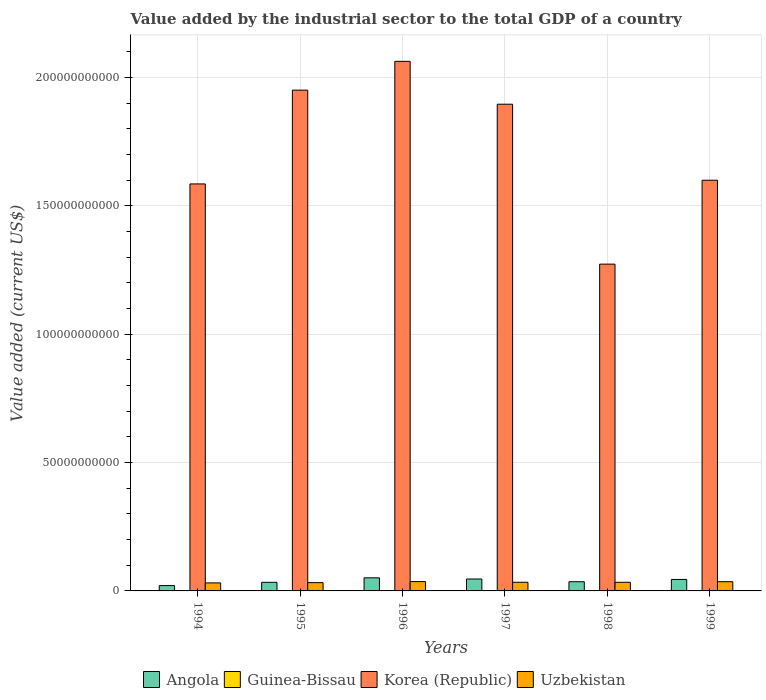How many different coloured bars are there?
Offer a very short reply. 4. How many groups of bars are there?
Provide a short and direct response. 6. Are the number of bars per tick equal to the number of legend labels?
Ensure brevity in your answer.  Yes. Are the number of bars on each tick of the X-axis equal?
Keep it short and to the point. Yes. How many bars are there on the 5th tick from the right?
Your answer should be very brief. 4. What is the value added by the industrial sector to the total GDP in Uzbekistan in 1995?
Give a very brief answer. 3.22e+09. Across all years, what is the maximum value added by the industrial sector to the total GDP in Uzbekistan?
Provide a succinct answer. 3.64e+09. Across all years, what is the minimum value added by the industrial sector to the total GDP in Guinea-Bissau?
Ensure brevity in your answer.  2.56e+07. In which year was the value added by the industrial sector to the total GDP in Angola maximum?
Provide a short and direct response. 1996. What is the total value added by the industrial sector to the total GDP in Guinea-Bissau in the graph?
Offer a very short reply. 1.77e+08. What is the difference between the value added by the industrial sector to the total GDP in Guinea-Bissau in 1996 and that in 1999?
Provide a succinct answer. 2.37e+06. What is the difference between the value added by the industrial sector to the total GDP in Korea (Republic) in 1998 and the value added by the industrial sector to the total GDP in Guinea-Bissau in 1995?
Keep it short and to the point. 1.27e+11. What is the average value added by the industrial sector to the total GDP in Korea (Republic) per year?
Provide a short and direct response. 1.73e+11. In the year 1995, what is the difference between the value added by the industrial sector to the total GDP in Guinea-Bissau and value added by the industrial sector to the total GDP in Angola?
Provide a succinct answer. -3.32e+09. In how many years, is the value added by the industrial sector to the total GDP in Uzbekistan greater than 110000000000 US$?
Offer a very short reply. 0. What is the ratio of the value added by the industrial sector to the total GDP in Angola in 1996 to that in 1997?
Offer a terse response. 1.1. Is the value added by the industrial sector to the total GDP in Uzbekistan in 1995 less than that in 1996?
Offer a very short reply. Yes. What is the difference between the highest and the second highest value added by the industrial sector to the total GDP in Uzbekistan?
Ensure brevity in your answer.  4.40e+07. What is the difference between the highest and the lowest value added by the industrial sector to the total GDP in Guinea-Bissau?
Provide a short and direct response. 1.48e+07. In how many years, is the value added by the industrial sector to the total GDP in Guinea-Bissau greater than the average value added by the industrial sector to the total GDP in Guinea-Bissau taken over all years?
Offer a very short reply. 1. Is the sum of the value added by the industrial sector to the total GDP in Guinea-Bissau in 1995 and 1997 greater than the maximum value added by the industrial sector to the total GDP in Angola across all years?
Provide a short and direct response. No. Is it the case that in every year, the sum of the value added by the industrial sector to the total GDP in Korea (Republic) and value added by the industrial sector to the total GDP in Uzbekistan is greater than the sum of value added by the industrial sector to the total GDP in Angola and value added by the industrial sector to the total GDP in Guinea-Bissau?
Keep it short and to the point. Yes. What does the 1st bar from the left in 1998 represents?
Your answer should be very brief. Angola. What does the 1st bar from the right in 1996 represents?
Provide a succinct answer. Uzbekistan. Is it the case that in every year, the sum of the value added by the industrial sector to the total GDP in Uzbekistan and value added by the industrial sector to the total GDP in Korea (Republic) is greater than the value added by the industrial sector to the total GDP in Guinea-Bissau?
Your answer should be very brief. Yes. How many years are there in the graph?
Your answer should be compact. 6. What is the difference between two consecutive major ticks on the Y-axis?
Your answer should be very brief. 5.00e+1. Are the values on the major ticks of Y-axis written in scientific E-notation?
Keep it short and to the point. No. Does the graph contain any zero values?
Make the answer very short. No. Where does the legend appear in the graph?
Provide a short and direct response. Bottom center. What is the title of the graph?
Offer a very short reply. Value added by the industrial sector to the total GDP of a country. Does "Indonesia" appear as one of the legend labels in the graph?
Offer a terse response. No. What is the label or title of the Y-axis?
Give a very brief answer. Value added (current US$). What is the Value added (current US$) of Angola in 1994?
Make the answer very short. 2.08e+09. What is the Value added (current US$) in Guinea-Bissau in 1994?
Your response must be concise. 2.56e+07. What is the Value added (current US$) in Korea (Republic) in 1994?
Give a very brief answer. 1.59e+11. What is the Value added (current US$) of Uzbekistan in 1994?
Your answer should be very brief. 3.13e+09. What is the Value added (current US$) of Angola in 1995?
Your answer should be very brief. 3.35e+09. What is the Value added (current US$) of Guinea-Bissau in 1995?
Your answer should be very brief. 2.91e+07. What is the Value added (current US$) of Korea (Republic) in 1995?
Offer a terse response. 1.95e+11. What is the Value added (current US$) of Uzbekistan in 1995?
Offer a very short reply. 3.22e+09. What is the Value added (current US$) of Angola in 1996?
Provide a succinct answer. 5.10e+09. What is the Value added (current US$) in Guinea-Bissau in 1996?
Offer a terse response. 2.95e+07. What is the Value added (current US$) in Korea (Republic) in 1996?
Provide a succinct answer. 2.06e+11. What is the Value added (current US$) of Uzbekistan in 1996?
Your answer should be very brief. 3.64e+09. What is the Value added (current US$) in Angola in 1997?
Your answer should be very brief. 4.65e+09. What is the Value added (current US$) in Guinea-Bissau in 1997?
Your response must be concise. 4.04e+07. What is the Value added (current US$) in Korea (Republic) in 1997?
Offer a terse response. 1.90e+11. What is the Value added (current US$) in Uzbekistan in 1997?
Make the answer very short. 3.37e+09. What is the Value added (current US$) of Angola in 1998?
Provide a short and direct response. 3.59e+09. What is the Value added (current US$) of Guinea-Bissau in 1998?
Provide a succinct answer. 2.58e+07. What is the Value added (current US$) of Korea (Republic) in 1998?
Make the answer very short. 1.27e+11. What is the Value added (current US$) in Uzbekistan in 1998?
Offer a terse response. 3.36e+09. What is the Value added (current US$) of Angola in 1999?
Provide a succinct answer. 4.47e+09. What is the Value added (current US$) of Guinea-Bissau in 1999?
Ensure brevity in your answer.  2.71e+07. What is the Value added (current US$) in Korea (Republic) in 1999?
Your answer should be very brief. 1.60e+11. What is the Value added (current US$) in Uzbekistan in 1999?
Provide a succinct answer. 3.59e+09. Across all years, what is the maximum Value added (current US$) in Angola?
Ensure brevity in your answer.  5.10e+09. Across all years, what is the maximum Value added (current US$) in Guinea-Bissau?
Make the answer very short. 4.04e+07. Across all years, what is the maximum Value added (current US$) of Korea (Republic)?
Keep it short and to the point. 2.06e+11. Across all years, what is the maximum Value added (current US$) in Uzbekistan?
Ensure brevity in your answer.  3.64e+09. Across all years, what is the minimum Value added (current US$) of Angola?
Provide a short and direct response. 2.08e+09. Across all years, what is the minimum Value added (current US$) of Guinea-Bissau?
Make the answer very short. 2.56e+07. Across all years, what is the minimum Value added (current US$) in Korea (Republic)?
Offer a very short reply. 1.27e+11. Across all years, what is the minimum Value added (current US$) of Uzbekistan?
Your response must be concise. 3.13e+09. What is the total Value added (current US$) in Angola in the graph?
Provide a succinct answer. 2.32e+1. What is the total Value added (current US$) in Guinea-Bissau in the graph?
Give a very brief answer. 1.77e+08. What is the total Value added (current US$) in Korea (Republic) in the graph?
Ensure brevity in your answer.  1.04e+12. What is the total Value added (current US$) in Uzbekistan in the graph?
Your answer should be compact. 2.03e+1. What is the difference between the Value added (current US$) of Angola in 1994 and that in 1995?
Offer a very short reply. -1.28e+09. What is the difference between the Value added (current US$) in Guinea-Bissau in 1994 and that in 1995?
Offer a very short reply. -3.55e+06. What is the difference between the Value added (current US$) in Korea (Republic) in 1994 and that in 1995?
Make the answer very short. -3.65e+1. What is the difference between the Value added (current US$) of Uzbekistan in 1994 and that in 1995?
Your answer should be very brief. -9.48e+07. What is the difference between the Value added (current US$) in Angola in 1994 and that in 1996?
Ensure brevity in your answer.  -3.03e+09. What is the difference between the Value added (current US$) in Guinea-Bissau in 1994 and that in 1996?
Give a very brief answer. -3.89e+06. What is the difference between the Value added (current US$) of Korea (Republic) in 1994 and that in 1996?
Keep it short and to the point. -4.78e+1. What is the difference between the Value added (current US$) of Uzbekistan in 1994 and that in 1996?
Your answer should be very brief. -5.10e+08. What is the difference between the Value added (current US$) of Angola in 1994 and that in 1997?
Ensure brevity in your answer.  -2.57e+09. What is the difference between the Value added (current US$) of Guinea-Bissau in 1994 and that in 1997?
Provide a short and direct response. -1.48e+07. What is the difference between the Value added (current US$) in Korea (Republic) in 1994 and that in 1997?
Your answer should be very brief. -3.11e+1. What is the difference between the Value added (current US$) of Uzbekistan in 1994 and that in 1997?
Provide a short and direct response. -2.44e+08. What is the difference between the Value added (current US$) in Angola in 1994 and that in 1998?
Keep it short and to the point. -1.51e+09. What is the difference between the Value added (current US$) of Guinea-Bissau in 1994 and that in 1998?
Offer a terse response. -1.60e+05. What is the difference between the Value added (current US$) of Korea (Republic) in 1994 and that in 1998?
Give a very brief answer. 3.13e+1. What is the difference between the Value added (current US$) of Uzbekistan in 1994 and that in 1998?
Provide a short and direct response. -2.29e+08. What is the difference between the Value added (current US$) in Angola in 1994 and that in 1999?
Your answer should be very brief. -2.40e+09. What is the difference between the Value added (current US$) in Guinea-Bissau in 1994 and that in 1999?
Ensure brevity in your answer.  -1.52e+06. What is the difference between the Value added (current US$) of Korea (Republic) in 1994 and that in 1999?
Make the answer very short. -1.44e+09. What is the difference between the Value added (current US$) of Uzbekistan in 1994 and that in 1999?
Offer a very short reply. -4.66e+08. What is the difference between the Value added (current US$) in Angola in 1995 and that in 1996?
Your answer should be very brief. -1.75e+09. What is the difference between the Value added (current US$) of Guinea-Bissau in 1995 and that in 1996?
Give a very brief answer. -3.42e+05. What is the difference between the Value added (current US$) in Korea (Republic) in 1995 and that in 1996?
Keep it short and to the point. -1.12e+1. What is the difference between the Value added (current US$) in Uzbekistan in 1995 and that in 1996?
Offer a terse response. -4.15e+08. What is the difference between the Value added (current US$) of Angola in 1995 and that in 1997?
Your response must be concise. -1.30e+09. What is the difference between the Value added (current US$) in Guinea-Bissau in 1995 and that in 1997?
Ensure brevity in your answer.  -1.12e+07. What is the difference between the Value added (current US$) in Korea (Republic) in 1995 and that in 1997?
Your response must be concise. 5.48e+09. What is the difference between the Value added (current US$) in Uzbekistan in 1995 and that in 1997?
Offer a terse response. -1.49e+08. What is the difference between the Value added (current US$) in Angola in 1995 and that in 1998?
Offer a terse response. -2.36e+08. What is the difference between the Value added (current US$) of Guinea-Bissau in 1995 and that in 1998?
Make the answer very short. 3.38e+06. What is the difference between the Value added (current US$) in Korea (Republic) in 1995 and that in 1998?
Your answer should be very brief. 6.78e+1. What is the difference between the Value added (current US$) in Uzbekistan in 1995 and that in 1998?
Keep it short and to the point. -1.34e+08. What is the difference between the Value added (current US$) in Angola in 1995 and that in 1999?
Give a very brief answer. -1.12e+09. What is the difference between the Value added (current US$) in Guinea-Bissau in 1995 and that in 1999?
Keep it short and to the point. 2.02e+06. What is the difference between the Value added (current US$) in Korea (Republic) in 1995 and that in 1999?
Your answer should be compact. 3.51e+1. What is the difference between the Value added (current US$) of Uzbekistan in 1995 and that in 1999?
Your answer should be very brief. -3.71e+08. What is the difference between the Value added (current US$) in Angola in 1996 and that in 1997?
Keep it short and to the point. 4.57e+08. What is the difference between the Value added (current US$) of Guinea-Bissau in 1996 and that in 1997?
Your answer should be very brief. -1.09e+07. What is the difference between the Value added (current US$) of Korea (Republic) in 1996 and that in 1997?
Give a very brief answer. 1.67e+1. What is the difference between the Value added (current US$) in Uzbekistan in 1996 and that in 1997?
Offer a terse response. 2.66e+08. What is the difference between the Value added (current US$) of Angola in 1996 and that in 1998?
Ensure brevity in your answer.  1.52e+09. What is the difference between the Value added (current US$) in Guinea-Bissau in 1996 and that in 1998?
Your response must be concise. 3.73e+06. What is the difference between the Value added (current US$) in Korea (Republic) in 1996 and that in 1998?
Your answer should be compact. 7.90e+1. What is the difference between the Value added (current US$) in Uzbekistan in 1996 and that in 1998?
Ensure brevity in your answer.  2.81e+08. What is the difference between the Value added (current US$) of Angola in 1996 and that in 1999?
Your answer should be very brief. 6.31e+08. What is the difference between the Value added (current US$) of Guinea-Bissau in 1996 and that in 1999?
Your answer should be very brief. 2.37e+06. What is the difference between the Value added (current US$) in Korea (Republic) in 1996 and that in 1999?
Offer a terse response. 4.63e+1. What is the difference between the Value added (current US$) in Uzbekistan in 1996 and that in 1999?
Provide a succinct answer. 4.40e+07. What is the difference between the Value added (current US$) of Angola in 1997 and that in 1998?
Keep it short and to the point. 1.06e+09. What is the difference between the Value added (current US$) of Guinea-Bissau in 1997 and that in 1998?
Offer a terse response. 1.46e+07. What is the difference between the Value added (current US$) of Korea (Republic) in 1997 and that in 1998?
Give a very brief answer. 6.23e+1. What is the difference between the Value added (current US$) in Uzbekistan in 1997 and that in 1998?
Offer a very short reply. 1.51e+07. What is the difference between the Value added (current US$) in Angola in 1997 and that in 1999?
Ensure brevity in your answer.  1.74e+08. What is the difference between the Value added (current US$) of Guinea-Bissau in 1997 and that in 1999?
Offer a terse response. 1.32e+07. What is the difference between the Value added (current US$) in Korea (Republic) in 1997 and that in 1999?
Offer a terse response. 2.96e+1. What is the difference between the Value added (current US$) in Uzbekistan in 1997 and that in 1999?
Your response must be concise. -2.22e+08. What is the difference between the Value added (current US$) in Angola in 1998 and that in 1999?
Provide a short and direct response. -8.85e+08. What is the difference between the Value added (current US$) of Guinea-Bissau in 1998 and that in 1999?
Offer a terse response. -1.36e+06. What is the difference between the Value added (current US$) in Korea (Republic) in 1998 and that in 1999?
Offer a very short reply. -3.27e+1. What is the difference between the Value added (current US$) in Uzbekistan in 1998 and that in 1999?
Ensure brevity in your answer.  -2.37e+08. What is the difference between the Value added (current US$) in Angola in 1994 and the Value added (current US$) in Guinea-Bissau in 1995?
Make the answer very short. 2.05e+09. What is the difference between the Value added (current US$) in Angola in 1994 and the Value added (current US$) in Korea (Republic) in 1995?
Keep it short and to the point. -1.93e+11. What is the difference between the Value added (current US$) of Angola in 1994 and the Value added (current US$) of Uzbekistan in 1995?
Keep it short and to the point. -1.15e+09. What is the difference between the Value added (current US$) of Guinea-Bissau in 1994 and the Value added (current US$) of Korea (Republic) in 1995?
Give a very brief answer. -1.95e+11. What is the difference between the Value added (current US$) of Guinea-Bissau in 1994 and the Value added (current US$) of Uzbekistan in 1995?
Keep it short and to the point. -3.20e+09. What is the difference between the Value added (current US$) of Korea (Republic) in 1994 and the Value added (current US$) of Uzbekistan in 1995?
Your answer should be compact. 1.55e+11. What is the difference between the Value added (current US$) in Angola in 1994 and the Value added (current US$) in Guinea-Bissau in 1996?
Provide a short and direct response. 2.05e+09. What is the difference between the Value added (current US$) of Angola in 1994 and the Value added (current US$) of Korea (Republic) in 1996?
Keep it short and to the point. -2.04e+11. What is the difference between the Value added (current US$) of Angola in 1994 and the Value added (current US$) of Uzbekistan in 1996?
Offer a very short reply. -1.56e+09. What is the difference between the Value added (current US$) of Guinea-Bissau in 1994 and the Value added (current US$) of Korea (Republic) in 1996?
Ensure brevity in your answer.  -2.06e+11. What is the difference between the Value added (current US$) in Guinea-Bissau in 1994 and the Value added (current US$) in Uzbekistan in 1996?
Ensure brevity in your answer.  -3.61e+09. What is the difference between the Value added (current US$) of Korea (Republic) in 1994 and the Value added (current US$) of Uzbekistan in 1996?
Your answer should be compact. 1.55e+11. What is the difference between the Value added (current US$) of Angola in 1994 and the Value added (current US$) of Guinea-Bissau in 1997?
Your answer should be compact. 2.04e+09. What is the difference between the Value added (current US$) of Angola in 1994 and the Value added (current US$) of Korea (Republic) in 1997?
Your answer should be compact. -1.88e+11. What is the difference between the Value added (current US$) of Angola in 1994 and the Value added (current US$) of Uzbekistan in 1997?
Make the answer very short. -1.30e+09. What is the difference between the Value added (current US$) of Guinea-Bissau in 1994 and the Value added (current US$) of Korea (Republic) in 1997?
Your answer should be compact. -1.90e+11. What is the difference between the Value added (current US$) of Guinea-Bissau in 1994 and the Value added (current US$) of Uzbekistan in 1997?
Provide a succinct answer. -3.35e+09. What is the difference between the Value added (current US$) of Korea (Republic) in 1994 and the Value added (current US$) of Uzbekistan in 1997?
Offer a very short reply. 1.55e+11. What is the difference between the Value added (current US$) of Angola in 1994 and the Value added (current US$) of Guinea-Bissau in 1998?
Provide a short and direct response. 2.05e+09. What is the difference between the Value added (current US$) of Angola in 1994 and the Value added (current US$) of Korea (Republic) in 1998?
Provide a succinct answer. -1.25e+11. What is the difference between the Value added (current US$) in Angola in 1994 and the Value added (current US$) in Uzbekistan in 1998?
Give a very brief answer. -1.28e+09. What is the difference between the Value added (current US$) of Guinea-Bissau in 1994 and the Value added (current US$) of Korea (Republic) in 1998?
Provide a succinct answer. -1.27e+11. What is the difference between the Value added (current US$) of Guinea-Bissau in 1994 and the Value added (current US$) of Uzbekistan in 1998?
Ensure brevity in your answer.  -3.33e+09. What is the difference between the Value added (current US$) in Korea (Republic) in 1994 and the Value added (current US$) in Uzbekistan in 1998?
Give a very brief answer. 1.55e+11. What is the difference between the Value added (current US$) of Angola in 1994 and the Value added (current US$) of Guinea-Bissau in 1999?
Your answer should be very brief. 2.05e+09. What is the difference between the Value added (current US$) in Angola in 1994 and the Value added (current US$) in Korea (Republic) in 1999?
Give a very brief answer. -1.58e+11. What is the difference between the Value added (current US$) in Angola in 1994 and the Value added (current US$) in Uzbekistan in 1999?
Your answer should be very brief. -1.52e+09. What is the difference between the Value added (current US$) in Guinea-Bissau in 1994 and the Value added (current US$) in Korea (Republic) in 1999?
Offer a terse response. -1.60e+11. What is the difference between the Value added (current US$) in Guinea-Bissau in 1994 and the Value added (current US$) in Uzbekistan in 1999?
Offer a terse response. -3.57e+09. What is the difference between the Value added (current US$) of Korea (Republic) in 1994 and the Value added (current US$) of Uzbekistan in 1999?
Provide a short and direct response. 1.55e+11. What is the difference between the Value added (current US$) of Angola in 1995 and the Value added (current US$) of Guinea-Bissau in 1996?
Provide a short and direct response. 3.32e+09. What is the difference between the Value added (current US$) of Angola in 1995 and the Value added (current US$) of Korea (Republic) in 1996?
Offer a very short reply. -2.03e+11. What is the difference between the Value added (current US$) in Angola in 1995 and the Value added (current US$) in Uzbekistan in 1996?
Give a very brief answer. -2.86e+08. What is the difference between the Value added (current US$) in Guinea-Bissau in 1995 and the Value added (current US$) in Korea (Republic) in 1996?
Offer a very short reply. -2.06e+11. What is the difference between the Value added (current US$) in Guinea-Bissau in 1995 and the Value added (current US$) in Uzbekistan in 1996?
Offer a very short reply. -3.61e+09. What is the difference between the Value added (current US$) of Korea (Republic) in 1995 and the Value added (current US$) of Uzbekistan in 1996?
Ensure brevity in your answer.  1.91e+11. What is the difference between the Value added (current US$) of Angola in 1995 and the Value added (current US$) of Guinea-Bissau in 1997?
Give a very brief answer. 3.31e+09. What is the difference between the Value added (current US$) of Angola in 1995 and the Value added (current US$) of Korea (Republic) in 1997?
Your answer should be compact. -1.86e+11. What is the difference between the Value added (current US$) of Angola in 1995 and the Value added (current US$) of Uzbekistan in 1997?
Make the answer very short. -2.00e+07. What is the difference between the Value added (current US$) of Guinea-Bissau in 1995 and the Value added (current US$) of Korea (Republic) in 1997?
Keep it short and to the point. -1.90e+11. What is the difference between the Value added (current US$) in Guinea-Bissau in 1995 and the Value added (current US$) in Uzbekistan in 1997?
Provide a succinct answer. -3.34e+09. What is the difference between the Value added (current US$) of Korea (Republic) in 1995 and the Value added (current US$) of Uzbekistan in 1997?
Your response must be concise. 1.92e+11. What is the difference between the Value added (current US$) of Angola in 1995 and the Value added (current US$) of Guinea-Bissau in 1998?
Provide a short and direct response. 3.33e+09. What is the difference between the Value added (current US$) of Angola in 1995 and the Value added (current US$) of Korea (Republic) in 1998?
Your answer should be very brief. -1.24e+11. What is the difference between the Value added (current US$) of Angola in 1995 and the Value added (current US$) of Uzbekistan in 1998?
Ensure brevity in your answer.  -4.94e+06. What is the difference between the Value added (current US$) in Guinea-Bissau in 1995 and the Value added (current US$) in Korea (Republic) in 1998?
Your answer should be very brief. -1.27e+11. What is the difference between the Value added (current US$) in Guinea-Bissau in 1995 and the Value added (current US$) in Uzbekistan in 1998?
Your response must be concise. -3.33e+09. What is the difference between the Value added (current US$) of Korea (Republic) in 1995 and the Value added (current US$) of Uzbekistan in 1998?
Offer a terse response. 1.92e+11. What is the difference between the Value added (current US$) of Angola in 1995 and the Value added (current US$) of Guinea-Bissau in 1999?
Keep it short and to the point. 3.33e+09. What is the difference between the Value added (current US$) in Angola in 1995 and the Value added (current US$) in Korea (Republic) in 1999?
Provide a succinct answer. -1.57e+11. What is the difference between the Value added (current US$) in Angola in 1995 and the Value added (current US$) in Uzbekistan in 1999?
Your answer should be compact. -2.42e+08. What is the difference between the Value added (current US$) in Guinea-Bissau in 1995 and the Value added (current US$) in Korea (Republic) in 1999?
Offer a terse response. -1.60e+11. What is the difference between the Value added (current US$) in Guinea-Bissau in 1995 and the Value added (current US$) in Uzbekistan in 1999?
Your answer should be very brief. -3.57e+09. What is the difference between the Value added (current US$) in Korea (Republic) in 1995 and the Value added (current US$) in Uzbekistan in 1999?
Your response must be concise. 1.92e+11. What is the difference between the Value added (current US$) in Angola in 1996 and the Value added (current US$) in Guinea-Bissau in 1997?
Your response must be concise. 5.06e+09. What is the difference between the Value added (current US$) in Angola in 1996 and the Value added (current US$) in Korea (Republic) in 1997?
Give a very brief answer. -1.85e+11. What is the difference between the Value added (current US$) in Angola in 1996 and the Value added (current US$) in Uzbekistan in 1997?
Ensure brevity in your answer.  1.73e+09. What is the difference between the Value added (current US$) in Guinea-Bissau in 1996 and the Value added (current US$) in Korea (Republic) in 1997?
Your answer should be very brief. -1.90e+11. What is the difference between the Value added (current US$) in Guinea-Bissau in 1996 and the Value added (current US$) in Uzbekistan in 1997?
Offer a terse response. -3.34e+09. What is the difference between the Value added (current US$) of Korea (Republic) in 1996 and the Value added (current US$) of Uzbekistan in 1997?
Provide a short and direct response. 2.03e+11. What is the difference between the Value added (current US$) in Angola in 1996 and the Value added (current US$) in Guinea-Bissau in 1998?
Your answer should be compact. 5.08e+09. What is the difference between the Value added (current US$) of Angola in 1996 and the Value added (current US$) of Korea (Republic) in 1998?
Your answer should be compact. -1.22e+11. What is the difference between the Value added (current US$) in Angola in 1996 and the Value added (current US$) in Uzbekistan in 1998?
Your answer should be very brief. 1.75e+09. What is the difference between the Value added (current US$) in Guinea-Bissau in 1996 and the Value added (current US$) in Korea (Republic) in 1998?
Your answer should be compact. -1.27e+11. What is the difference between the Value added (current US$) of Guinea-Bissau in 1996 and the Value added (current US$) of Uzbekistan in 1998?
Provide a short and direct response. -3.33e+09. What is the difference between the Value added (current US$) in Korea (Republic) in 1996 and the Value added (current US$) in Uzbekistan in 1998?
Offer a terse response. 2.03e+11. What is the difference between the Value added (current US$) in Angola in 1996 and the Value added (current US$) in Guinea-Bissau in 1999?
Give a very brief answer. 5.08e+09. What is the difference between the Value added (current US$) in Angola in 1996 and the Value added (current US$) in Korea (Republic) in 1999?
Offer a terse response. -1.55e+11. What is the difference between the Value added (current US$) in Angola in 1996 and the Value added (current US$) in Uzbekistan in 1999?
Your answer should be very brief. 1.51e+09. What is the difference between the Value added (current US$) in Guinea-Bissau in 1996 and the Value added (current US$) in Korea (Republic) in 1999?
Provide a short and direct response. -1.60e+11. What is the difference between the Value added (current US$) in Guinea-Bissau in 1996 and the Value added (current US$) in Uzbekistan in 1999?
Ensure brevity in your answer.  -3.56e+09. What is the difference between the Value added (current US$) of Korea (Republic) in 1996 and the Value added (current US$) of Uzbekistan in 1999?
Offer a very short reply. 2.03e+11. What is the difference between the Value added (current US$) of Angola in 1997 and the Value added (current US$) of Guinea-Bissau in 1998?
Ensure brevity in your answer.  4.62e+09. What is the difference between the Value added (current US$) of Angola in 1997 and the Value added (current US$) of Korea (Republic) in 1998?
Give a very brief answer. -1.23e+11. What is the difference between the Value added (current US$) in Angola in 1997 and the Value added (current US$) in Uzbekistan in 1998?
Make the answer very short. 1.29e+09. What is the difference between the Value added (current US$) of Guinea-Bissau in 1997 and the Value added (current US$) of Korea (Republic) in 1998?
Your answer should be very brief. -1.27e+11. What is the difference between the Value added (current US$) in Guinea-Bissau in 1997 and the Value added (current US$) in Uzbekistan in 1998?
Offer a very short reply. -3.32e+09. What is the difference between the Value added (current US$) in Korea (Republic) in 1997 and the Value added (current US$) in Uzbekistan in 1998?
Provide a short and direct response. 1.86e+11. What is the difference between the Value added (current US$) of Angola in 1997 and the Value added (current US$) of Guinea-Bissau in 1999?
Make the answer very short. 4.62e+09. What is the difference between the Value added (current US$) in Angola in 1997 and the Value added (current US$) in Korea (Republic) in 1999?
Offer a terse response. -1.55e+11. What is the difference between the Value added (current US$) in Angola in 1997 and the Value added (current US$) in Uzbekistan in 1999?
Your response must be concise. 1.05e+09. What is the difference between the Value added (current US$) of Guinea-Bissau in 1997 and the Value added (current US$) of Korea (Republic) in 1999?
Your answer should be very brief. -1.60e+11. What is the difference between the Value added (current US$) in Guinea-Bissau in 1997 and the Value added (current US$) in Uzbekistan in 1999?
Provide a succinct answer. -3.55e+09. What is the difference between the Value added (current US$) in Korea (Republic) in 1997 and the Value added (current US$) in Uzbekistan in 1999?
Your response must be concise. 1.86e+11. What is the difference between the Value added (current US$) of Angola in 1998 and the Value added (current US$) of Guinea-Bissau in 1999?
Provide a succinct answer. 3.56e+09. What is the difference between the Value added (current US$) of Angola in 1998 and the Value added (current US$) of Korea (Republic) in 1999?
Your response must be concise. -1.56e+11. What is the difference between the Value added (current US$) of Angola in 1998 and the Value added (current US$) of Uzbekistan in 1999?
Keep it short and to the point. -5.48e+06. What is the difference between the Value added (current US$) in Guinea-Bissau in 1998 and the Value added (current US$) in Korea (Republic) in 1999?
Give a very brief answer. -1.60e+11. What is the difference between the Value added (current US$) of Guinea-Bissau in 1998 and the Value added (current US$) of Uzbekistan in 1999?
Ensure brevity in your answer.  -3.57e+09. What is the difference between the Value added (current US$) in Korea (Republic) in 1998 and the Value added (current US$) in Uzbekistan in 1999?
Provide a short and direct response. 1.24e+11. What is the average Value added (current US$) in Angola per year?
Your answer should be very brief. 3.87e+09. What is the average Value added (current US$) of Guinea-Bissau per year?
Keep it short and to the point. 2.96e+07. What is the average Value added (current US$) of Korea (Republic) per year?
Your answer should be very brief. 1.73e+11. What is the average Value added (current US$) of Uzbekistan per year?
Keep it short and to the point. 3.39e+09. In the year 1994, what is the difference between the Value added (current US$) of Angola and Value added (current US$) of Guinea-Bissau?
Keep it short and to the point. 2.05e+09. In the year 1994, what is the difference between the Value added (current US$) of Angola and Value added (current US$) of Korea (Republic)?
Keep it short and to the point. -1.57e+11. In the year 1994, what is the difference between the Value added (current US$) of Angola and Value added (current US$) of Uzbekistan?
Your answer should be very brief. -1.05e+09. In the year 1994, what is the difference between the Value added (current US$) of Guinea-Bissau and Value added (current US$) of Korea (Republic)?
Provide a succinct answer. -1.59e+11. In the year 1994, what is the difference between the Value added (current US$) in Guinea-Bissau and Value added (current US$) in Uzbekistan?
Your answer should be compact. -3.10e+09. In the year 1994, what is the difference between the Value added (current US$) in Korea (Republic) and Value added (current US$) in Uzbekistan?
Your response must be concise. 1.55e+11. In the year 1995, what is the difference between the Value added (current US$) in Angola and Value added (current US$) in Guinea-Bissau?
Make the answer very short. 3.32e+09. In the year 1995, what is the difference between the Value added (current US$) of Angola and Value added (current US$) of Korea (Republic)?
Your response must be concise. -1.92e+11. In the year 1995, what is the difference between the Value added (current US$) in Angola and Value added (current US$) in Uzbekistan?
Your response must be concise. 1.29e+08. In the year 1995, what is the difference between the Value added (current US$) in Guinea-Bissau and Value added (current US$) in Korea (Republic)?
Provide a short and direct response. -1.95e+11. In the year 1995, what is the difference between the Value added (current US$) of Guinea-Bissau and Value added (current US$) of Uzbekistan?
Provide a succinct answer. -3.19e+09. In the year 1995, what is the difference between the Value added (current US$) of Korea (Republic) and Value added (current US$) of Uzbekistan?
Give a very brief answer. 1.92e+11. In the year 1996, what is the difference between the Value added (current US$) in Angola and Value added (current US$) in Guinea-Bissau?
Your answer should be very brief. 5.08e+09. In the year 1996, what is the difference between the Value added (current US$) in Angola and Value added (current US$) in Korea (Republic)?
Ensure brevity in your answer.  -2.01e+11. In the year 1996, what is the difference between the Value added (current US$) in Angola and Value added (current US$) in Uzbekistan?
Provide a short and direct response. 1.47e+09. In the year 1996, what is the difference between the Value added (current US$) of Guinea-Bissau and Value added (current US$) of Korea (Republic)?
Your response must be concise. -2.06e+11. In the year 1996, what is the difference between the Value added (current US$) of Guinea-Bissau and Value added (current US$) of Uzbekistan?
Your answer should be compact. -3.61e+09. In the year 1996, what is the difference between the Value added (current US$) in Korea (Republic) and Value added (current US$) in Uzbekistan?
Ensure brevity in your answer.  2.03e+11. In the year 1997, what is the difference between the Value added (current US$) of Angola and Value added (current US$) of Guinea-Bissau?
Make the answer very short. 4.61e+09. In the year 1997, what is the difference between the Value added (current US$) of Angola and Value added (current US$) of Korea (Republic)?
Provide a succinct answer. -1.85e+11. In the year 1997, what is the difference between the Value added (current US$) of Angola and Value added (current US$) of Uzbekistan?
Your answer should be compact. 1.28e+09. In the year 1997, what is the difference between the Value added (current US$) of Guinea-Bissau and Value added (current US$) of Korea (Republic)?
Offer a very short reply. -1.90e+11. In the year 1997, what is the difference between the Value added (current US$) of Guinea-Bissau and Value added (current US$) of Uzbekistan?
Your answer should be very brief. -3.33e+09. In the year 1997, what is the difference between the Value added (current US$) of Korea (Republic) and Value added (current US$) of Uzbekistan?
Ensure brevity in your answer.  1.86e+11. In the year 1998, what is the difference between the Value added (current US$) of Angola and Value added (current US$) of Guinea-Bissau?
Provide a succinct answer. 3.56e+09. In the year 1998, what is the difference between the Value added (current US$) of Angola and Value added (current US$) of Korea (Republic)?
Provide a short and direct response. -1.24e+11. In the year 1998, what is the difference between the Value added (current US$) of Angola and Value added (current US$) of Uzbekistan?
Make the answer very short. 2.31e+08. In the year 1998, what is the difference between the Value added (current US$) of Guinea-Bissau and Value added (current US$) of Korea (Republic)?
Your response must be concise. -1.27e+11. In the year 1998, what is the difference between the Value added (current US$) of Guinea-Bissau and Value added (current US$) of Uzbekistan?
Provide a succinct answer. -3.33e+09. In the year 1998, what is the difference between the Value added (current US$) of Korea (Republic) and Value added (current US$) of Uzbekistan?
Give a very brief answer. 1.24e+11. In the year 1999, what is the difference between the Value added (current US$) of Angola and Value added (current US$) of Guinea-Bissau?
Your answer should be very brief. 4.45e+09. In the year 1999, what is the difference between the Value added (current US$) of Angola and Value added (current US$) of Korea (Republic)?
Give a very brief answer. -1.56e+11. In the year 1999, what is the difference between the Value added (current US$) in Angola and Value added (current US$) in Uzbekistan?
Your answer should be very brief. 8.80e+08. In the year 1999, what is the difference between the Value added (current US$) in Guinea-Bissau and Value added (current US$) in Korea (Republic)?
Your response must be concise. -1.60e+11. In the year 1999, what is the difference between the Value added (current US$) of Guinea-Bissau and Value added (current US$) of Uzbekistan?
Make the answer very short. -3.57e+09. In the year 1999, what is the difference between the Value added (current US$) of Korea (Republic) and Value added (current US$) of Uzbekistan?
Give a very brief answer. 1.56e+11. What is the ratio of the Value added (current US$) of Angola in 1994 to that in 1995?
Provide a short and direct response. 0.62. What is the ratio of the Value added (current US$) of Guinea-Bissau in 1994 to that in 1995?
Ensure brevity in your answer.  0.88. What is the ratio of the Value added (current US$) in Korea (Republic) in 1994 to that in 1995?
Make the answer very short. 0.81. What is the ratio of the Value added (current US$) of Uzbekistan in 1994 to that in 1995?
Make the answer very short. 0.97. What is the ratio of the Value added (current US$) in Angola in 1994 to that in 1996?
Make the answer very short. 0.41. What is the ratio of the Value added (current US$) of Guinea-Bissau in 1994 to that in 1996?
Give a very brief answer. 0.87. What is the ratio of the Value added (current US$) in Korea (Republic) in 1994 to that in 1996?
Offer a very short reply. 0.77. What is the ratio of the Value added (current US$) of Uzbekistan in 1994 to that in 1996?
Your response must be concise. 0.86. What is the ratio of the Value added (current US$) of Angola in 1994 to that in 1997?
Your answer should be very brief. 0.45. What is the ratio of the Value added (current US$) of Guinea-Bissau in 1994 to that in 1997?
Keep it short and to the point. 0.63. What is the ratio of the Value added (current US$) in Korea (Republic) in 1994 to that in 1997?
Provide a succinct answer. 0.84. What is the ratio of the Value added (current US$) in Uzbekistan in 1994 to that in 1997?
Ensure brevity in your answer.  0.93. What is the ratio of the Value added (current US$) of Angola in 1994 to that in 1998?
Provide a short and direct response. 0.58. What is the ratio of the Value added (current US$) in Guinea-Bissau in 1994 to that in 1998?
Your response must be concise. 0.99. What is the ratio of the Value added (current US$) of Korea (Republic) in 1994 to that in 1998?
Your answer should be compact. 1.25. What is the ratio of the Value added (current US$) of Uzbekistan in 1994 to that in 1998?
Ensure brevity in your answer.  0.93. What is the ratio of the Value added (current US$) of Angola in 1994 to that in 1999?
Your response must be concise. 0.46. What is the ratio of the Value added (current US$) of Guinea-Bissau in 1994 to that in 1999?
Ensure brevity in your answer.  0.94. What is the ratio of the Value added (current US$) in Korea (Republic) in 1994 to that in 1999?
Offer a very short reply. 0.99. What is the ratio of the Value added (current US$) of Uzbekistan in 1994 to that in 1999?
Offer a very short reply. 0.87. What is the ratio of the Value added (current US$) in Angola in 1995 to that in 1996?
Provide a succinct answer. 0.66. What is the ratio of the Value added (current US$) of Guinea-Bissau in 1995 to that in 1996?
Provide a short and direct response. 0.99. What is the ratio of the Value added (current US$) in Korea (Republic) in 1995 to that in 1996?
Keep it short and to the point. 0.95. What is the ratio of the Value added (current US$) of Uzbekistan in 1995 to that in 1996?
Offer a terse response. 0.89. What is the ratio of the Value added (current US$) of Angola in 1995 to that in 1997?
Make the answer very short. 0.72. What is the ratio of the Value added (current US$) in Guinea-Bissau in 1995 to that in 1997?
Your answer should be very brief. 0.72. What is the ratio of the Value added (current US$) in Korea (Republic) in 1995 to that in 1997?
Provide a short and direct response. 1.03. What is the ratio of the Value added (current US$) of Uzbekistan in 1995 to that in 1997?
Make the answer very short. 0.96. What is the ratio of the Value added (current US$) of Angola in 1995 to that in 1998?
Ensure brevity in your answer.  0.93. What is the ratio of the Value added (current US$) of Guinea-Bissau in 1995 to that in 1998?
Ensure brevity in your answer.  1.13. What is the ratio of the Value added (current US$) of Korea (Republic) in 1995 to that in 1998?
Keep it short and to the point. 1.53. What is the ratio of the Value added (current US$) in Angola in 1995 to that in 1999?
Provide a succinct answer. 0.75. What is the ratio of the Value added (current US$) in Guinea-Bissau in 1995 to that in 1999?
Keep it short and to the point. 1.07. What is the ratio of the Value added (current US$) in Korea (Republic) in 1995 to that in 1999?
Keep it short and to the point. 1.22. What is the ratio of the Value added (current US$) of Uzbekistan in 1995 to that in 1999?
Ensure brevity in your answer.  0.9. What is the ratio of the Value added (current US$) in Angola in 1996 to that in 1997?
Offer a very short reply. 1.1. What is the ratio of the Value added (current US$) in Guinea-Bissau in 1996 to that in 1997?
Ensure brevity in your answer.  0.73. What is the ratio of the Value added (current US$) of Korea (Republic) in 1996 to that in 1997?
Give a very brief answer. 1.09. What is the ratio of the Value added (current US$) of Uzbekistan in 1996 to that in 1997?
Ensure brevity in your answer.  1.08. What is the ratio of the Value added (current US$) of Angola in 1996 to that in 1998?
Keep it short and to the point. 1.42. What is the ratio of the Value added (current US$) of Guinea-Bissau in 1996 to that in 1998?
Give a very brief answer. 1.14. What is the ratio of the Value added (current US$) of Korea (Republic) in 1996 to that in 1998?
Make the answer very short. 1.62. What is the ratio of the Value added (current US$) in Uzbekistan in 1996 to that in 1998?
Provide a succinct answer. 1.08. What is the ratio of the Value added (current US$) of Angola in 1996 to that in 1999?
Your answer should be very brief. 1.14. What is the ratio of the Value added (current US$) of Guinea-Bissau in 1996 to that in 1999?
Give a very brief answer. 1.09. What is the ratio of the Value added (current US$) in Korea (Republic) in 1996 to that in 1999?
Give a very brief answer. 1.29. What is the ratio of the Value added (current US$) of Uzbekistan in 1996 to that in 1999?
Ensure brevity in your answer.  1.01. What is the ratio of the Value added (current US$) in Angola in 1997 to that in 1998?
Your response must be concise. 1.3. What is the ratio of the Value added (current US$) of Guinea-Bissau in 1997 to that in 1998?
Your response must be concise. 1.57. What is the ratio of the Value added (current US$) of Korea (Republic) in 1997 to that in 1998?
Your response must be concise. 1.49. What is the ratio of the Value added (current US$) in Angola in 1997 to that in 1999?
Offer a very short reply. 1.04. What is the ratio of the Value added (current US$) in Guinea-Bissau in 1997 to that in 1999?
Provide a short and direct response. 1.49. What is the ratio of the Value added (current US$) of Korea (Republic) in 1997 to that in 1999?
Keep it short and to the point. 1.19. What is the ratio of the Value added (current US$) in Uzbekistan in 1997 to that in 1999?
Provide a succinct answer. 0.94. What is the ratio of the Value added (current US$) in Angola in 1998 to that in 1999?
Offer a very short reply. 0.8. What is the ratio of the Value added (current US$) of Guinea-Bissau in 1998 to that in 1999?
Keep it short and to the point. 0.95. What is the ratio of the Value added (current US$) of Korea (Republic) in 1998 to that in 1999?
Offer a terse response. 0.8. What is the ratio of the Value added (current US$) in Uzbekistan in 1998 to that in 1999?
Give a very brief answer. 0.93. What is the difference between the highest and the second highest Value added (current US$) in Angola?
Keep it short and to the point. 4.57e+08. What is the difference between the highest and the second highest Value added (current US$) in Guinea-Bissau?
Give a very brief answer. 1.09e+07. What is the difference between the highest and the second highest Value added (current US$) in Korea (Republic)?
Offer a very short reply. 1.12e+1. What is the difference between the highest and the second highest Value added (current US$) of Uzbekistan?
Keep it short and to the point. 4.40e+07. What is the difference between the highest and the lowest Value added (current US$) of Angola?
Give a very brief answer. 3.03e+09. What is the difference between the highest and the lowest Value added (current US$) in Guinea-Bissau?
Provide a succinct answer. 1.48e+07. What is the difference between the highest and the lowest Value added (current US$) in Korea (Republic)?
Make the answer very short. 7.90e+1. What is the difference between the highest and the lowest Value added (current US$) of Uzbekistan?
Your response must be concise. 5.10e+08. 